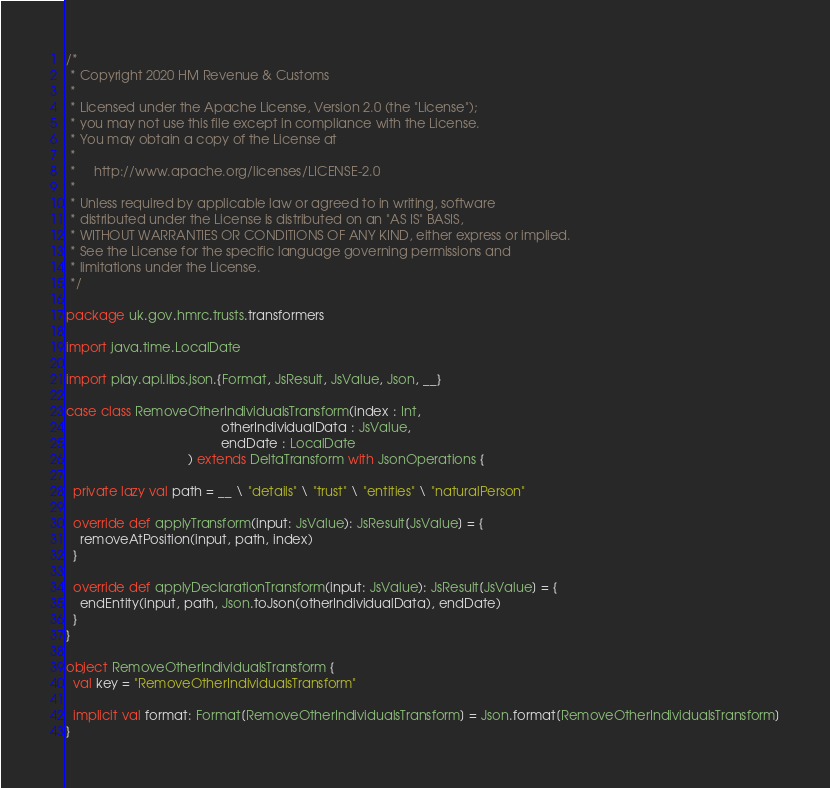<code> <loc_0><loc_0><loc_500><loc_500><_Scala_>/*
 * Copyright 2020 HM Revenue & Customs
 *
 * Licensed under the Apache License, Version 2.0 (the "License");
 * you may not use this file except in compliance with the License.
 * You may obtain a copy of the License at
 *
 *     http://www.apache.org/licenses/LICENSE-2.0
 *
 * Unless required by applicable law or agreed to in writing, software
 * distributed under the License is distributed on an "AS IS" BASIS,
 * WITHOUT WARRANTIES OR CONDITIONS OF ANY KIND, either express or implied.
 * See the License for the specific language governing permissions and
 * limitations under the License.
 */

package uk.gov.hmrc.trusts.transformers

import java.time.LocalDate

import play.api.libs.json.{Format, JsResult, JsValue, Json, __}

case class RemoveOtherIndividualsTransform(index : Int,
                                           otherIndividualData : JsValue,
                                           endDate : LocalDate
                                  ) extends DeltaTransform with JsonOperations {

  private lazy val path = __ \ "details" \ "trust" \ "entities" \ "naturalPerson"

  override def applyTransform(input: JsValue): JsResult[JsValue] = {
    removeAtPosition(input, path, index)
  }

  override def applyDeclarationTransform(input: JsValue): JsResult[JsValue] = {
    endEntity(input, path, Json.toJson(otherIndividualData), endDate)
  }
}

object RemoveOtherIndividualsTransform {
  val key = "RemoveOtherIndividualsTransform"

  implicit val format: Format[RemoveOtherIndividualsTransform] = Json.format[RemoveOtherIndividualsTransform]
}
</code> 